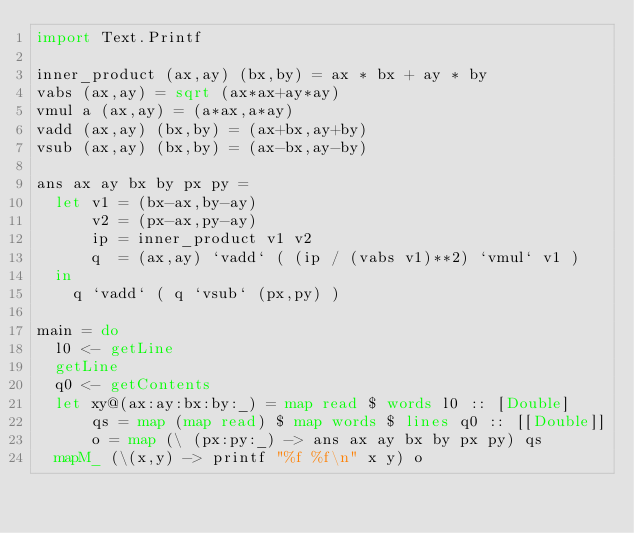Convert code to text. <code><loc_0><loc_0><loc_500><loc_500><_Haskell_>import Text.Printf

inner_product (ax,ay) (bx,by) = ax * bx + ay * by
vabs (ax,ay) = sqrt (ax*ax+ay*ay)
vmul a (ax,ay) = (a*ax,a*ay)
vadd (ax,ay) (bx,by) = (ax+bx,ay+by)
vsub (ax,ay) (bx,by) = (ax-bx,ay-by)

ans ax ay bx by px py =
  let v1 = (bx-ax,by-ay)
      v2 = (px-ax,py-ay)
      ip = inner_product v1 v2
      q  = (ax,ay) `vadd` ( (ip / (vabs v1)**2) `vmul` v1 )
  in
    q `vadd` ( q `vsub` (px,py) )
    
main = do
  l0 <- getLine
  getLine
  q0 <- getContents
  let xy@(ax:ay:bx:by:_) = map read $ words l0 :: [Double]
      qs = map (map read) $ map words $ lines q0 :: [[Double]]
      o = map (\ (px:py:_) -> ans ax ay bx by px py) qs
  mapM_ (\(x,y) -> printf "%f %f\n" x y) o
  </code> 